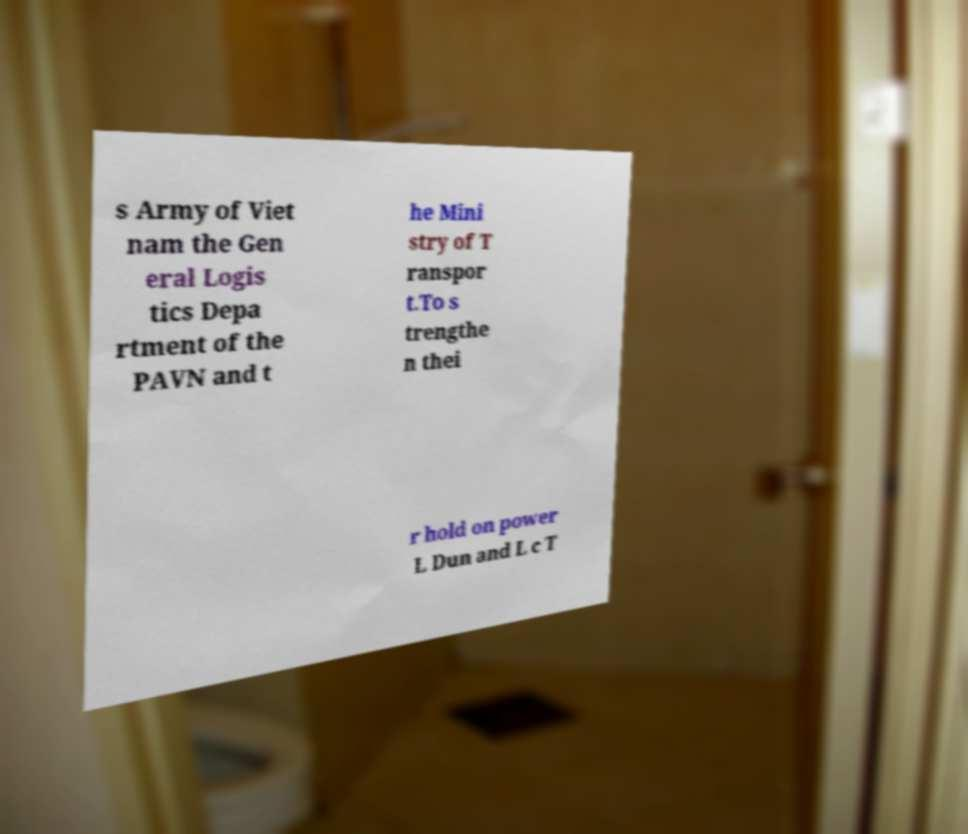Can you read and provide the text displayed in the image?This photo seems to have some interesting text. Can you extract and type it out for me? s Army of Viet nam the Gen eral Logis tics Depa rtment of the PAVN and t he Mini stry of T ranspor t.To s trengthe n thei r hold on power L Dun and L c T 